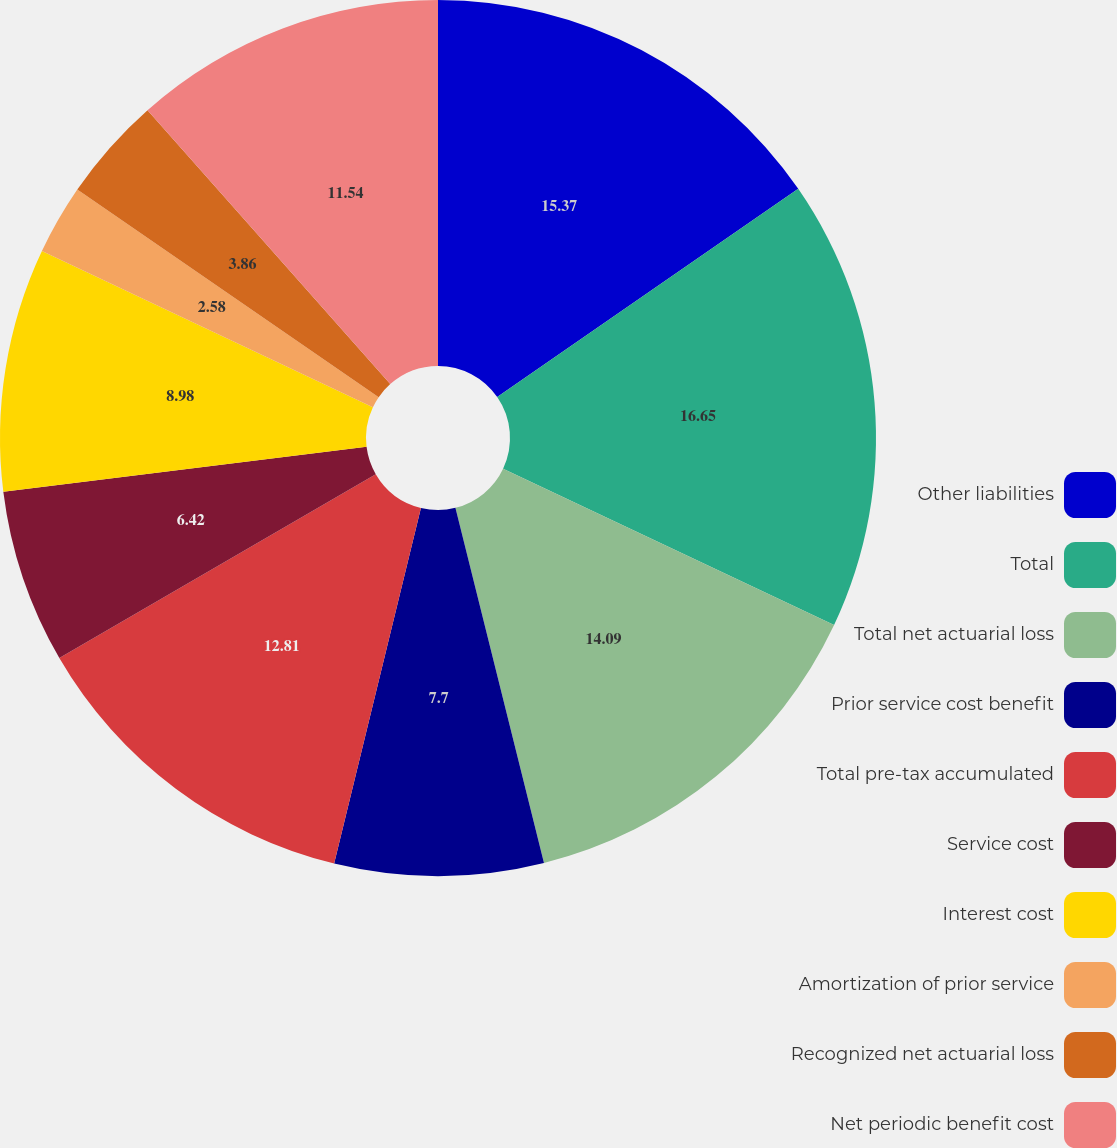Convert chart. <chart><loc_0><loc_0><loc_500><loc_500><pie_chart><fcel>Other liabilities<fcel>Total<fcel>Total net actuarial loss<fcel>Prior service cost benefit<fcel>Total pre-tax accumulated<fcel>Service cost<fcel>Interest cost<fcel>Amortization of prior service<fcel>Recognized net actuarial loss<fcel>Net periodic benefit cost<nl><fcel>15.37%<fcel>16.65%<fcel>14.09%<fcel>7.7%<fcel>12.81%<fcel>6.42%<fcel>8.98%<fcel>2.58%<fcel>3.86%<fcel>11.54%<nl></chart> 